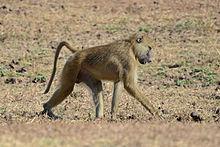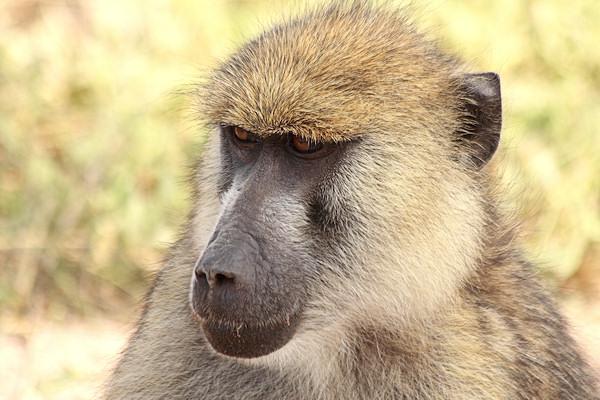The first image is the image on the left, the second image is the image on the right. Assess this claim about the two images: "At least one monkey is on all fours.". Correct or not? Answer yes or no. Yes. 